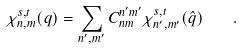Convert formula to latex. <formula><loc_0><loc_0><loc_500><loc_500>\chi _ { n , m } ^ { s , t } ( q ) = \sum _ { n ^ { \prime } , m ^ { \prime } } C _ { n m } ^ { n ^ { \prime } m ^ { \prime } } \chi _ { n ^ { \prime } , m ^ { \prime } } ^ { s , t } ( \hat { q } ) \quad .</formula> 